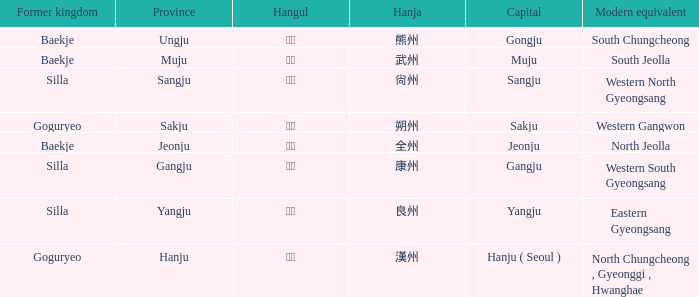What are the current analogues for the province of "hanju"? North Chungcheong , Gyeonggi , Hwanghae. 